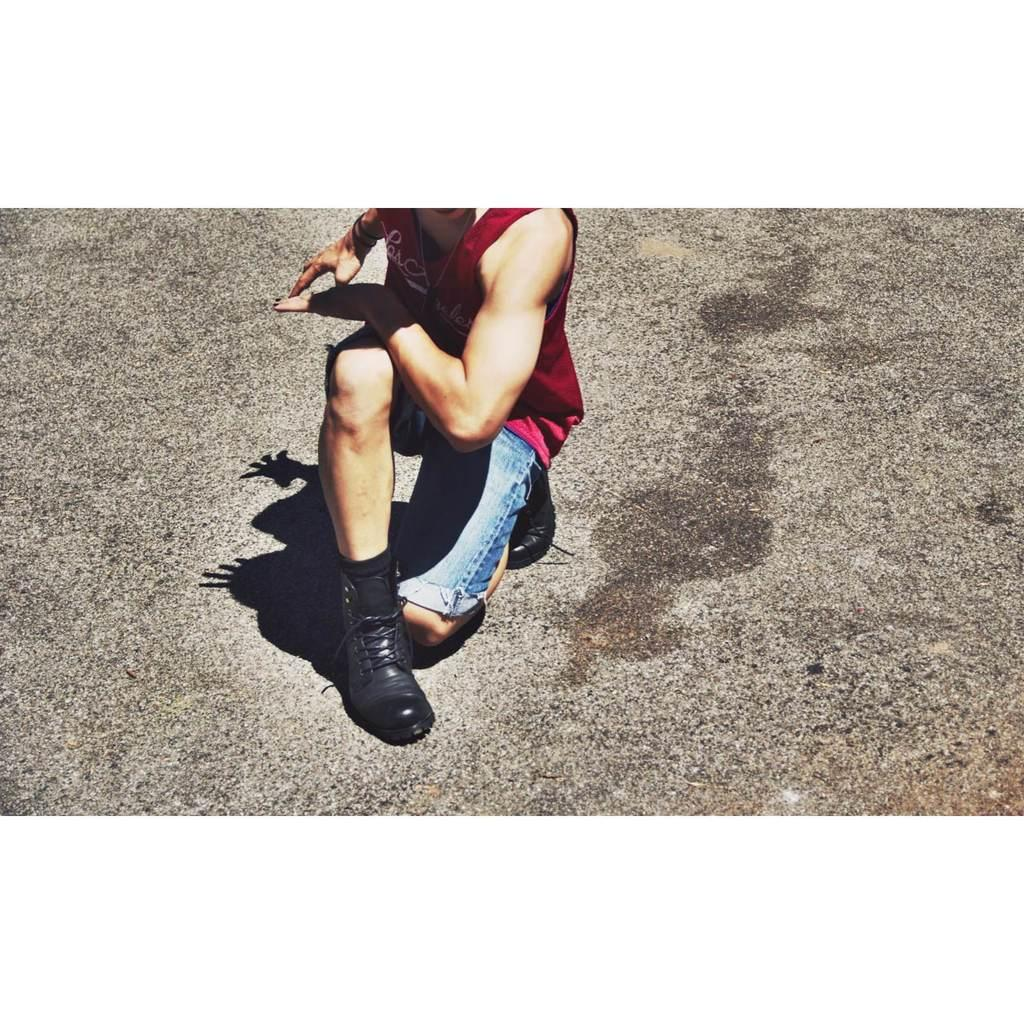What is the person in the image doing? The person in the image is on their knee. What can be seen at the bottom of the image? There is a road visible at the bottom of the image. What type of linen is being used to clean the road in the image? There is no linen or cleaning activity present in the image. How many oranges can be seen on the person's knee in the image? There are no oranges present in the image. 